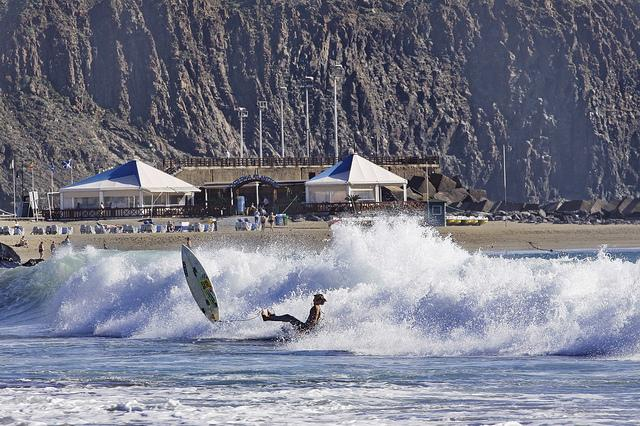Why is he not on the surfboard? Please explain your reasoning. fell off. Surfing is a difficult sport that requires a lot of balance. 